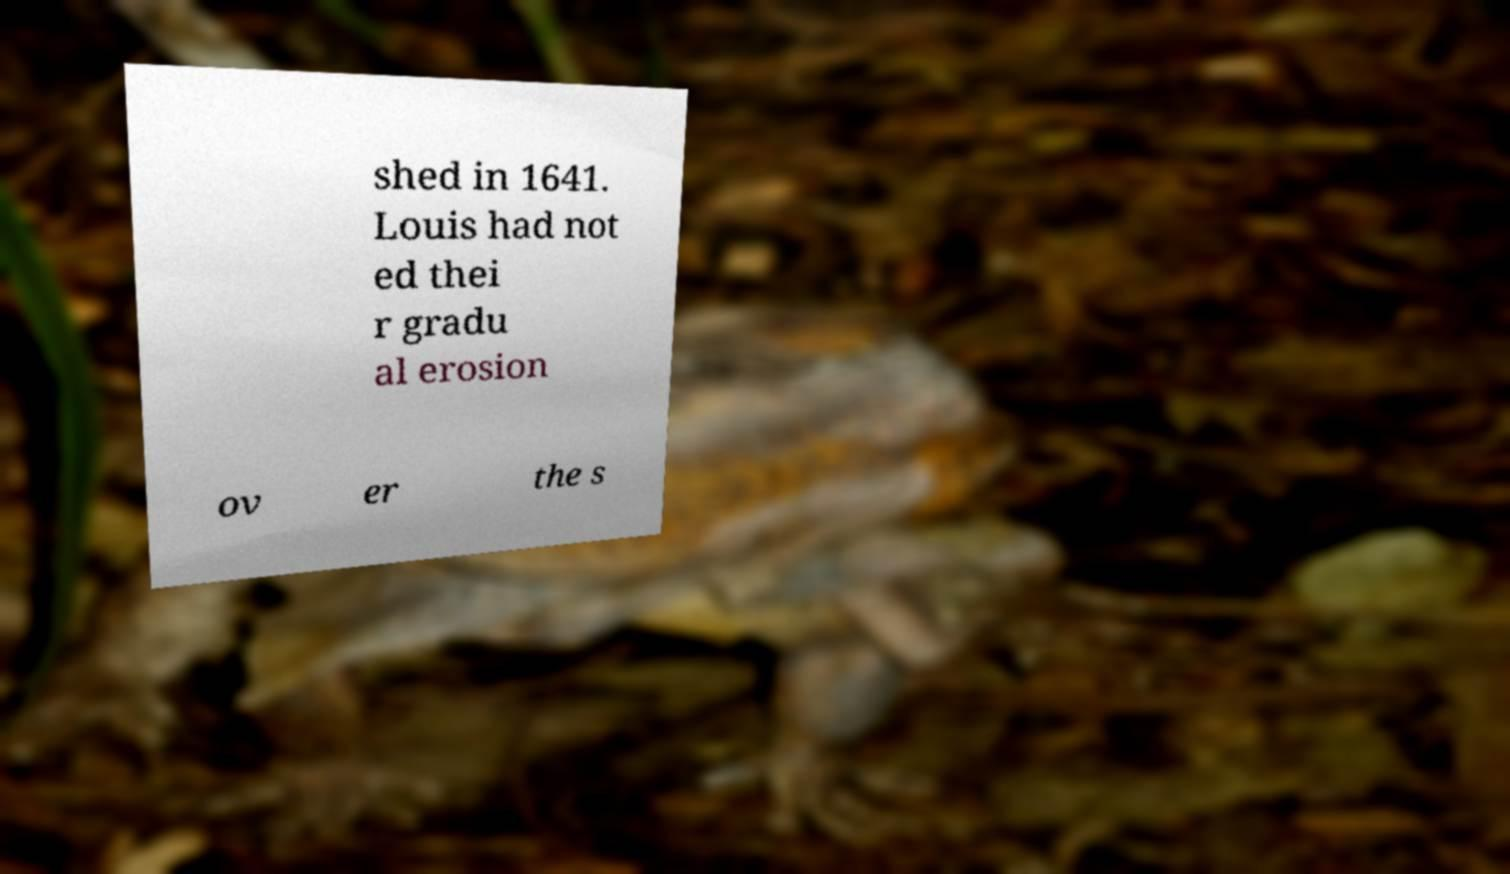I need the written content from this picture converted into text. Can you do that? shed in 1641. Louis had not ed thei r gradu al erosion ov er the s 